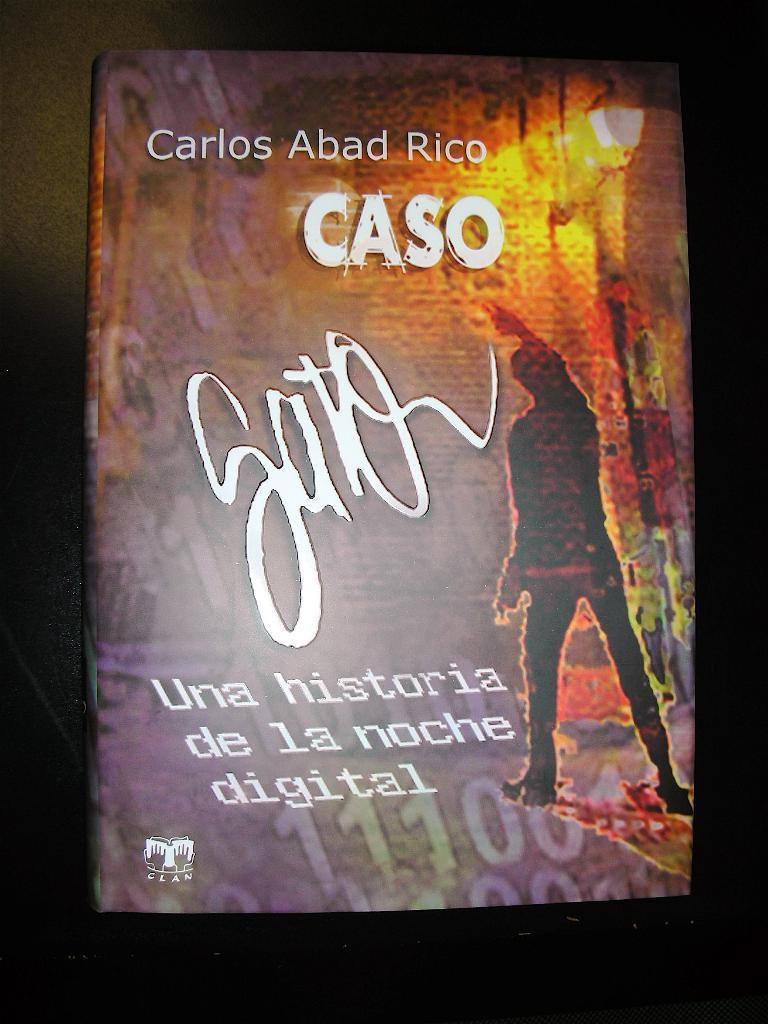<image>
Share a concise interpretation of the image provided. The front to cover of a book by Carlos Abad Rico 